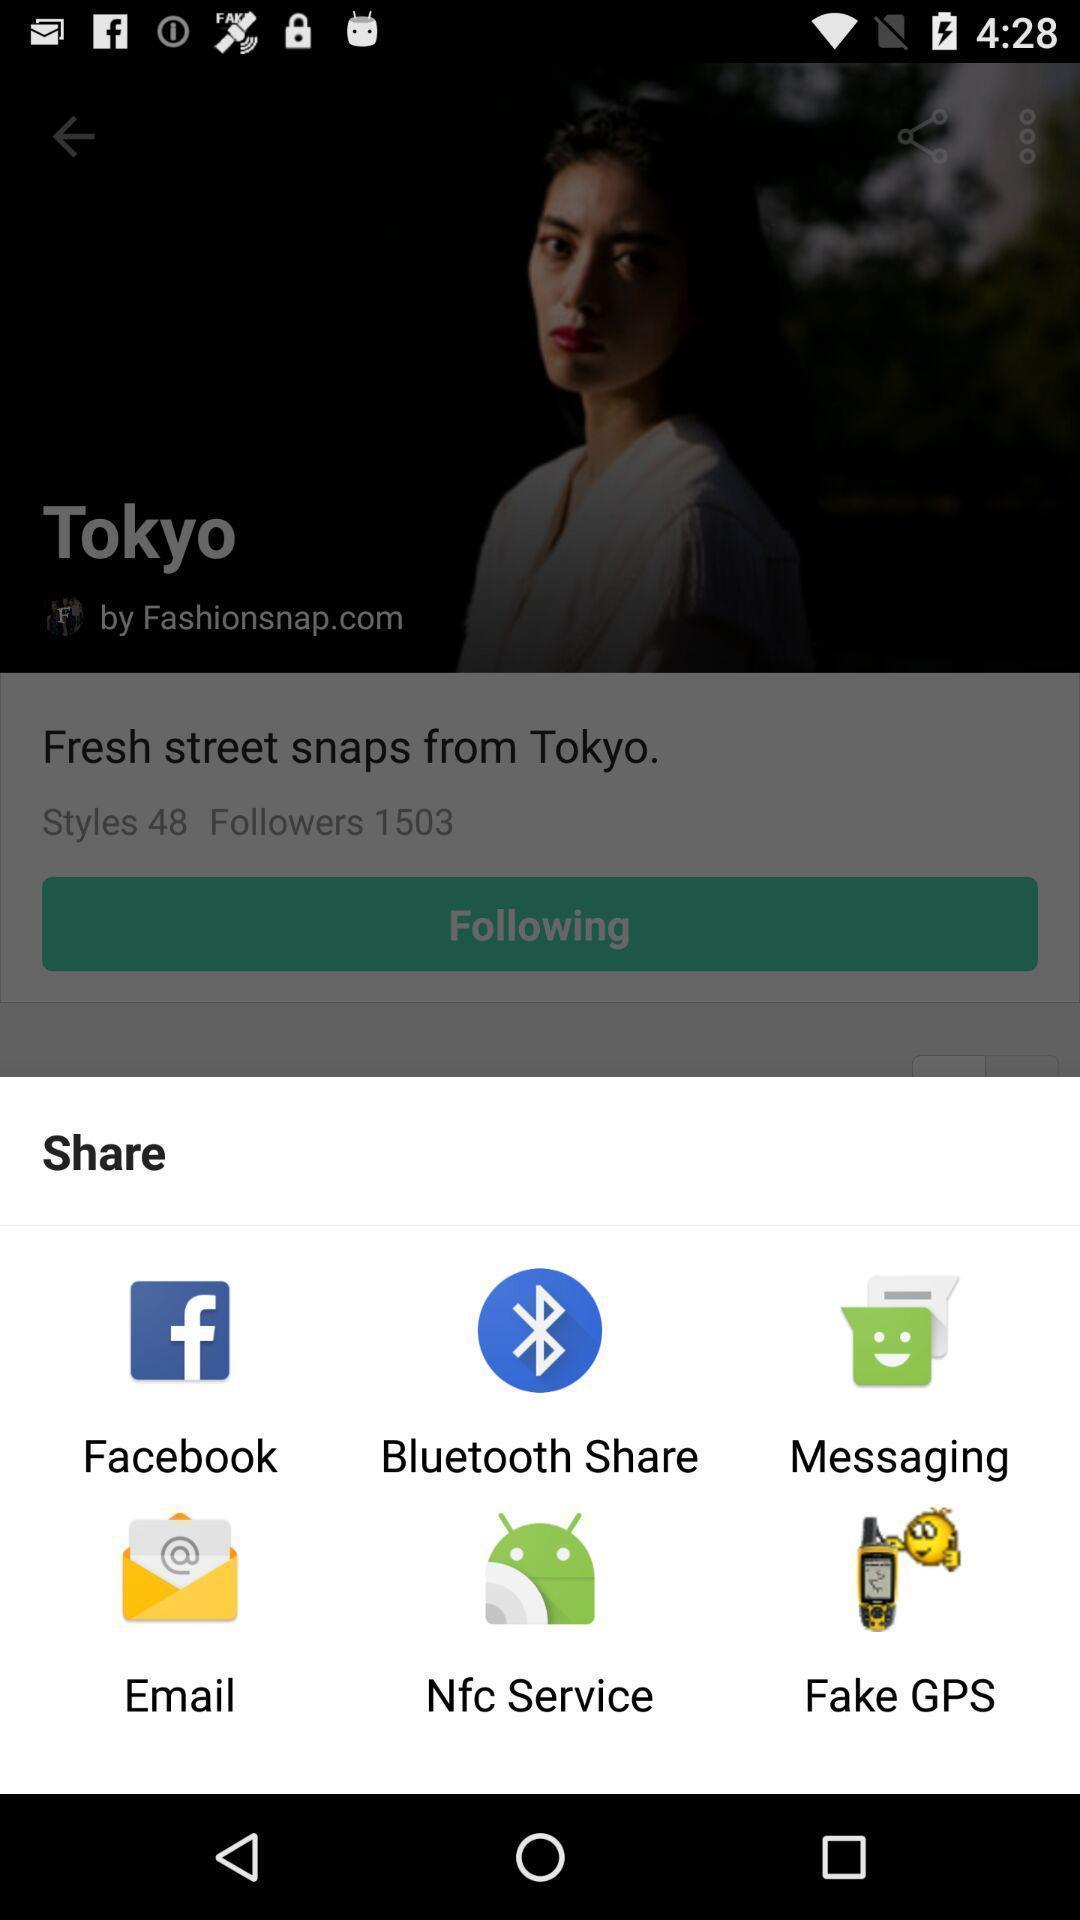Tell me what you see in this picture. Pop-up showing different sharing applications. 